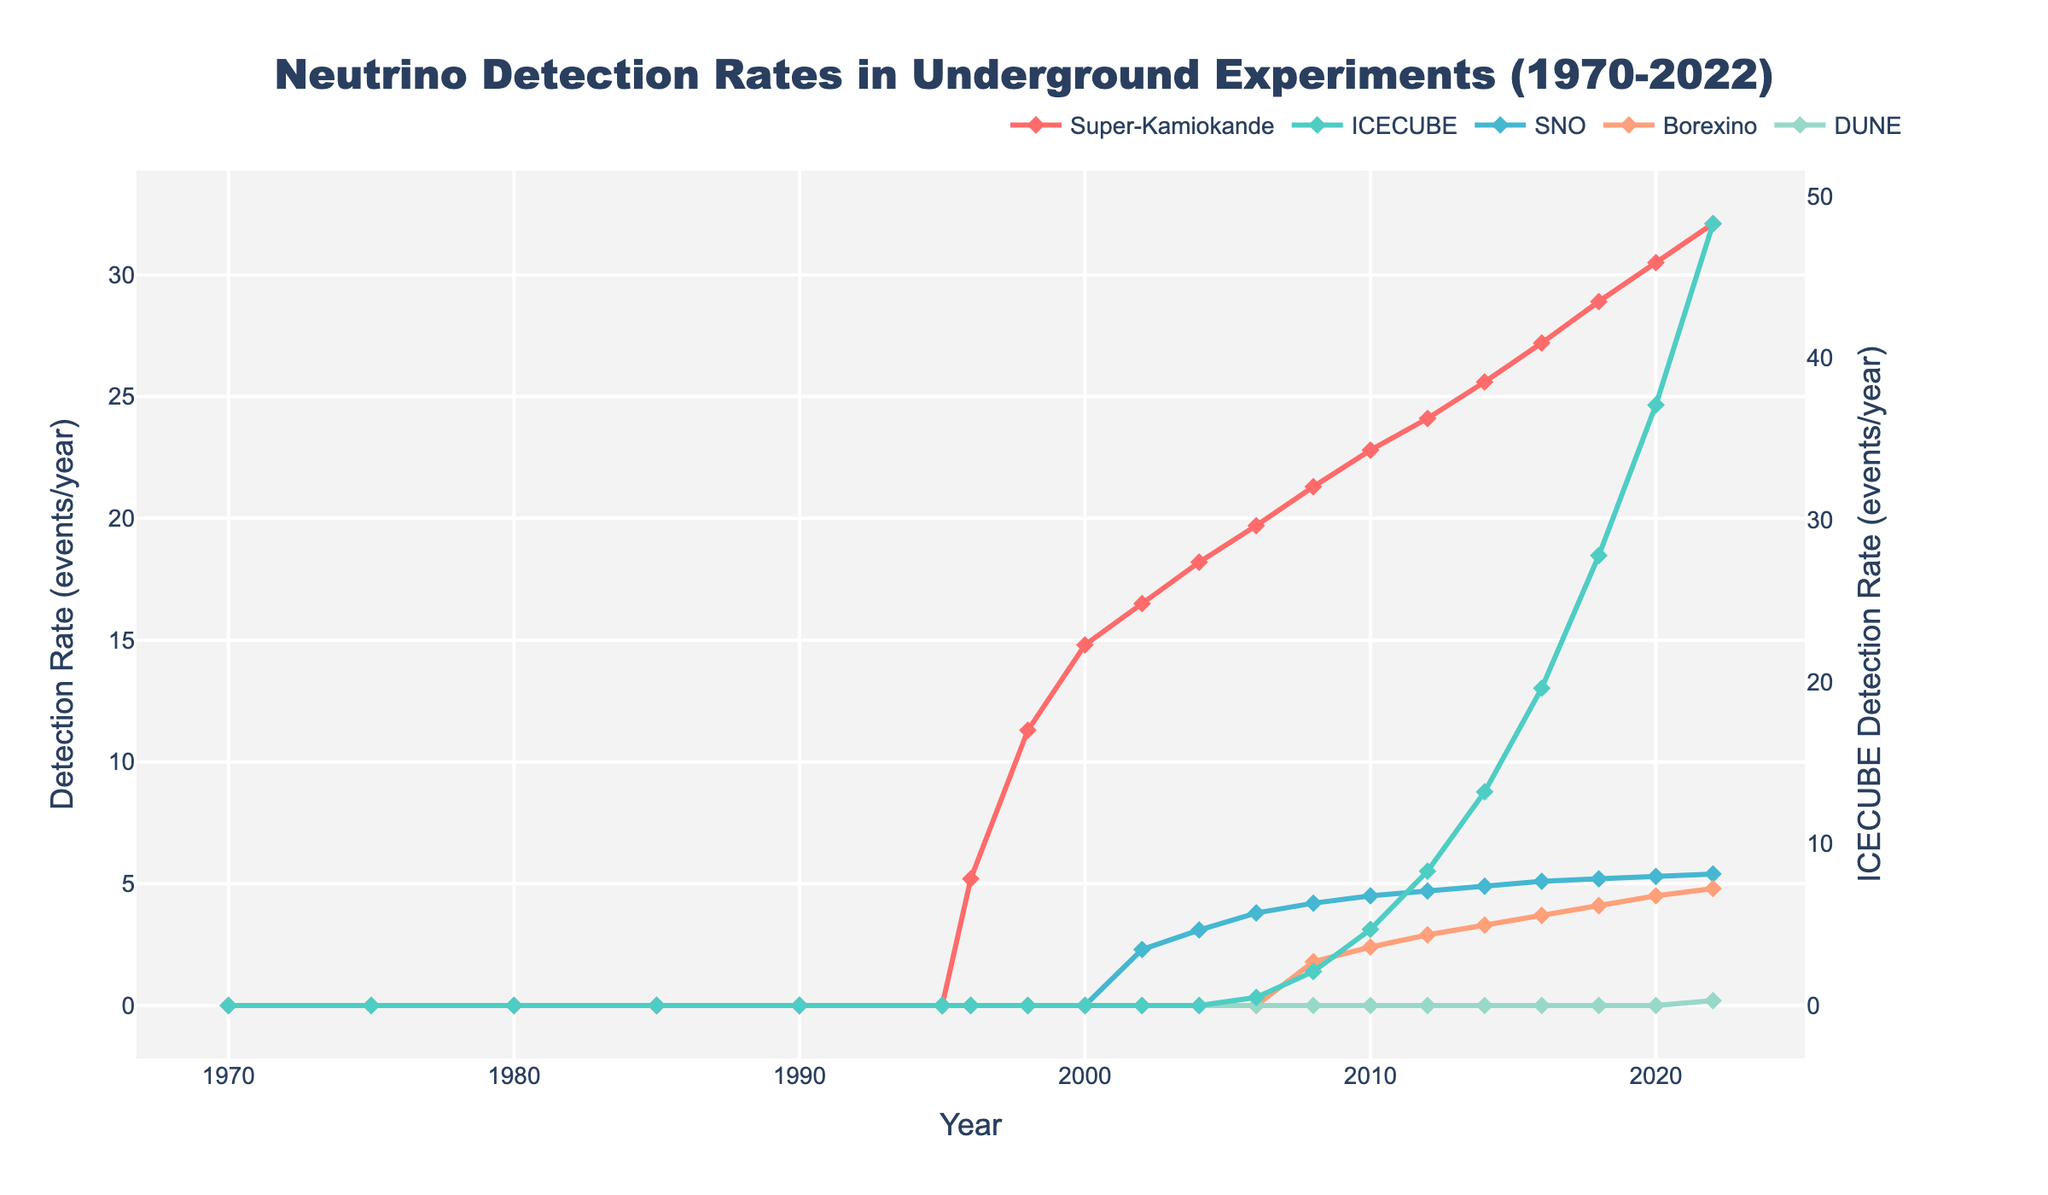What was the detection rate for Super-Kamiokande in 1996? Look at the graph and find the data point for Super-Kamiokande for the year 1996. The label shows a value of 5.2 events/year.
Answer: 5.2 events/year How did the detection rate of ICECUBE change from 2010 to 2022? Compare the data points for ICECUBE in 2010 and 2022. In 2010, the rate was 4.7 events/year, and by 2022, it increased to 48.3 events/year. The change is 48.3 - 4.7 = 43.6 events/year.
Answer: Increased by 43.6 events/year Which experiment had the highest detection rate in 2020? Look at the data points for each experiment in 2020. Compare the values: Super-Kamiokande (30.5), ICECUBE (37.1), SNO (5.3), Borexino (4.5), DUNE (0). ICECUBE has the highest rate of 37.1 events/year.
Answer: ICECUBE What is the average detection rate of SNO from 2002 to 2022? Sum the detection rates for SNO from 2002 to 2022: 2.3 + 3.1 + 3.8 + 4.2 + 4.5 + 4.7 + 4.9 + 5.1 + 5.2 + 5.3 + 5.4 = 48.5. Divide by the number of years considered: 48.5 / 11 = 4.41 events/year.
Answer: 4.41 events/year Between which consecutive years did Super-Kamiokande see the greatest increase in detection rate? Calculate the year-on-year increase for Super-Kamiokande: 
1996-1998: 11.3 - 5.2 = 6.1, 
1998-2000: 14.8 - 11.3 = 3.5, 
2000-2002: 16.5 - 14.8 = 1.7, 
2002-2004: 18.2 - 16.5 = 1.7, 
2004-2006: 19.7 - 18.2 = 1.5, 
2006-2008: 21.3 - 19.7 = 1.6, 
2008-2010: 22.8 - 21.3 = 1.5, 
2010-2012: 24.1 - 22.8 = 1.3, 
2012-2014: 25.6 - 24.1 = 1.5, 
2014-2016: 27.2 - 25.6 = 1.6, 
2016-2018: 28.9 - 27.2 = 1.7, 
2018-2020: 30.5 - 28.9 = 1.6, 
2020-2022: 32.1 - 30.5 = 1.6. The greatest increase occurred between 1996 and 1998: 6.1 events/year.
Answer: 1996-1998 By how much did the detection rate of Borexino increase from 2008 to 2022? Look at the detection rates for Borexino in 2008 and 2022: 1.8 and 4.8 events/year respectively. The increase is 4.8 - 1.8 = 3.0 events/year.
Answer: 3.0 events/year What color represents SNO in the plot? Identify the line associated with SNO by looking at the color in the plot. The line for SNO is represented in blue as it matches the provided color palette.
Answer: Blue Which two experiments had approximately the same detection rate in 2016? Compare the detection rates for the year 2016: Super-Kamiokande (27.2), ICECUBE (19.6), SNO (5.1), Borexino (3.7). SNO and Borexino both had approximately similar rates (5.1 and 3.7 respectively), but no two experiments have exactly the same. Hence, there are no two experiments with an approximate same detection rate in this year.
Answer: None What trend do you observe in the detection rate for Super-Kamiokande from 1996 to 2022? Observe the line for Super-Kamiokande from 1996 to 2022. It shows a consistent upward trend, starting at 5.2 events/year in 1996 and reaching 32.1 events/year in 2022.
Answer: Upward trend 